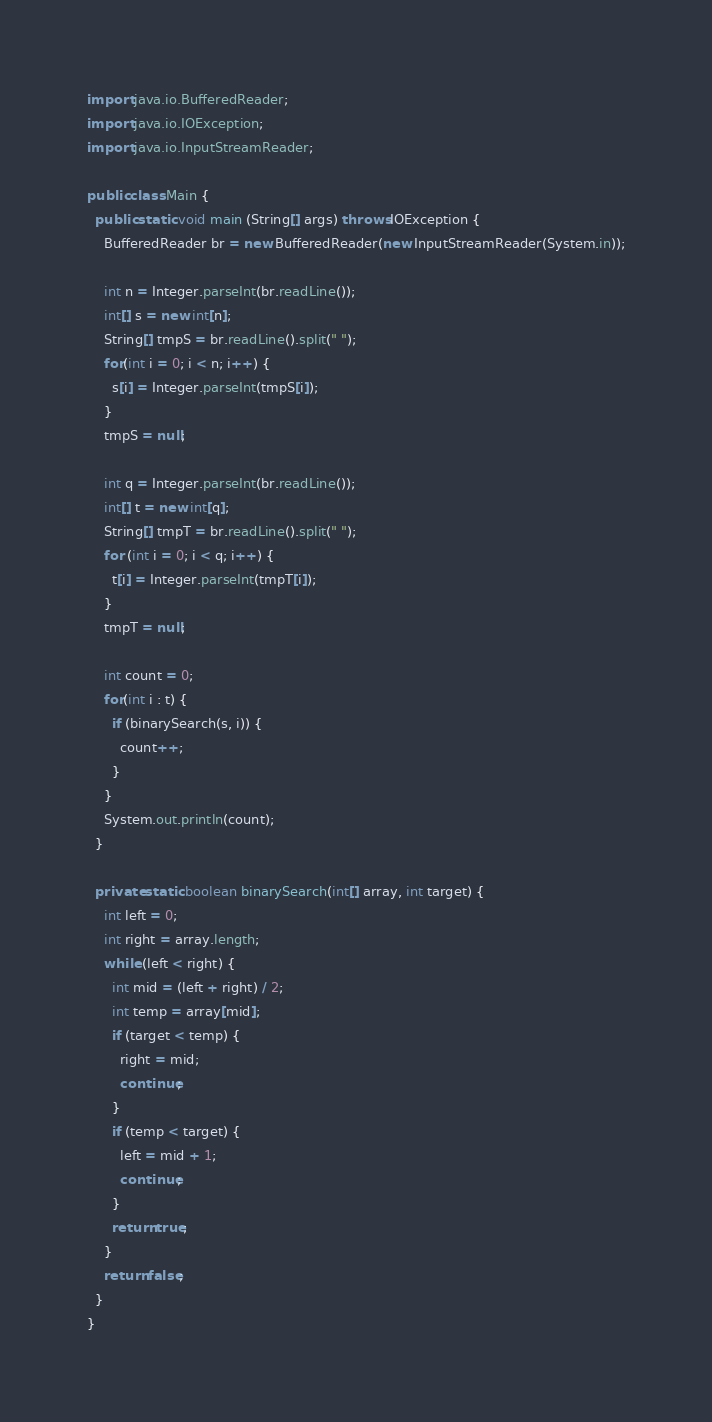Convert code to text. <code><loc_0><loc_0><loc_500><loc_500><_Java_>import java.io.BufferedReader;
import java.io.IOException;
import java.io.InputStreamReader;

public class Main {
  public static void main (String[] args) throws IOException {
    BufferedReader br = new BufferedReader(new InputStreamReader(System.in));

    int n = Integer.parseInt(br.readLine());
    int[] s = new int[n];
    String[] tmpS = br.readLine().split(" ");
    for(int i = 0; i < n; i++) {
      s[i] = Integer.parseInt(tmpS[i]);
    }
    tmpS = null;

    int q = Integer.parseInt(br.readLine());
    int[] t = new int[q];
    String[] tmpT = br.readLine().split(" ");
    for (int i = 0; i < q; i++) {
      t[i] = Integer.parseInt(tmpT[i]);
    }
    tmpT = null;

    int count = 0;
    for(int i : t) {
      if (binarySearch(s, i)) {
        count++;
      }
    }
    System.out.println(count);
  }

  private static boolean binarySearch(int[] array, int target) {
    int left = 0;
    int right = array.length;
    while (left < right) {
      int mid = (left + right) / 2;
      int temp = array[mid];
      if (target < temp) {
        right = mid;
        continue;
      }
      if (temp < target) {
        left = mid + 1;
        continue;
      }
      return true;
    }
    return false;
  }
}</code> 